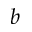Convert formula to latex. <formula><loc_0><loc_0><loc_500><loc_500>b</formula> 